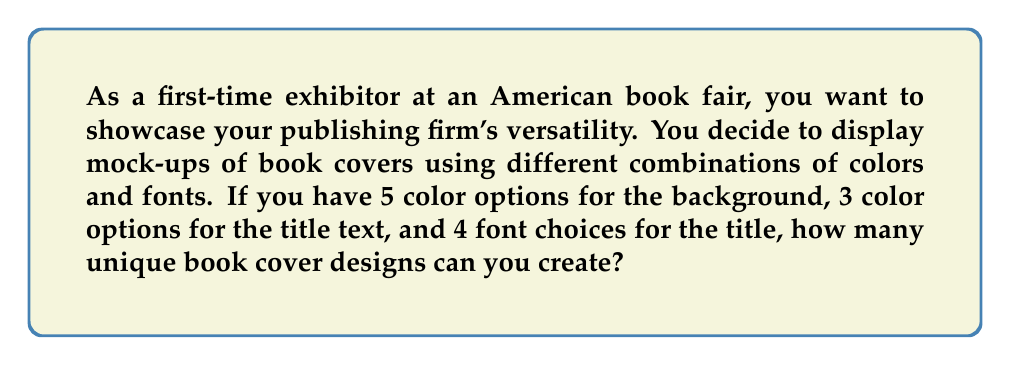Give your solution to this math problem. Let's break this down step-by-step:

1. We have three independent choices to make for each book cover:
   - Background color
   - Title text color
   - Title font

2. For each choice, we can use the Multiplication Principle of Counting:
   - There are 5 options for background color
   - There are 3 options for title text color
   - There are 4 options for title font

3. According to the Multiplication Principle, when we have independent choices, we multiply the number of options for each choice:

   $$ \text{Total number of designs} = \text{Background colors} \times \text{Text colors} \times \text{Fonts} $$

4. Substituting the values:

   $$ \text{Total number of designs} = 5 \times 3 \times 4 $$

5. Calculating the result:

   $$ \text{Total number of designs} = 60 $$

Therefore, you can create 60 unique book cover designs with the given options.
Answer: 60 unique designs 